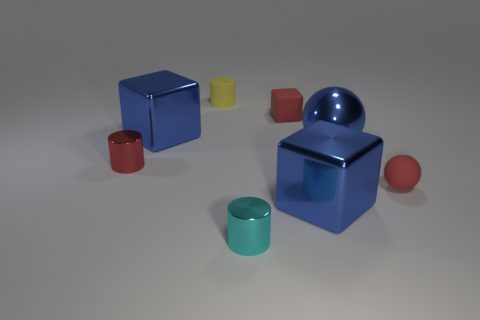The large shiny ball is what color?
Your answer should be very brief. Blue. There is a large blue sphere; are there any yellow things in front of it?
Provide a short and direct response. No. Do the big ball and the rubber ball have the same color?
Offer a very short reply. No. What number of small spheres are the same color as the large metal sphere?
Offer a terse response. 0. What size is the matte ball that is in front of the blue object that is on the left side of the cyan thing?
Your response must be concise. Small. The small yellow matte object has what shape?
Ensure brevity in your answer.  Cylinder. There is a block in front of the tiny ball; what is its material?
Your answer should be very brief. Metal. What is the color of the metal block in front of the big metallic block that is on the left side of the large blue block that is to the right of the red cube?
Offer a very short reply. Blue. There is a rubber block that is the same size as the cyan metallic thing; what color is it?
Provide a short and direct response. Red. What number of matte objects are tiny spheres or blue blocks?
Give a very brief answer. 1. 